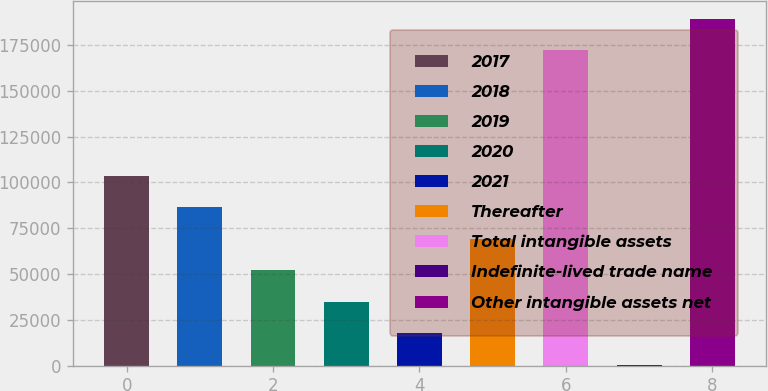Convert chart. <chart><loc_0><loc_0><loc_500><loc_500><bar_chart><fcel>2017<fcel>2018<fcel>2019<fcel>2020<fcel>2021<fcel>Thereafter<fcel>Total intangible assets<fcel>Indefinite-lived trade name<fcel>Other intangible assets net<nl><fcel>103714<fcel>86488<fcel>52035.6<fcel>34809.4<fcel>17583.2<fcel>69261.8<fcel>172262<fcel>357<fcel>189488<nl></chart> 